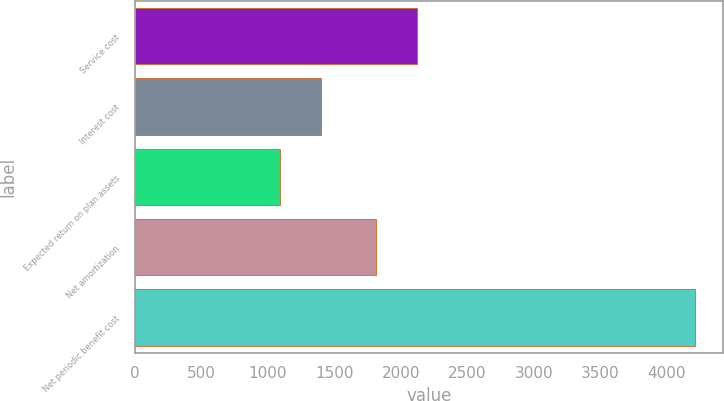Convert chart to OTSL. <chart><loc_0><loc_0><loc_500><loc_500><bar_chart><fcel>Service cost<fcel>Interest cost<fcel>Expected return on plan assets<fcel>Net amortization<fcel>Net periodic benefit cost<nl><fcel>2121.5<fcel>1400.5<fcel>1088<fcel>1809<fcel>4213<nl></chart> 